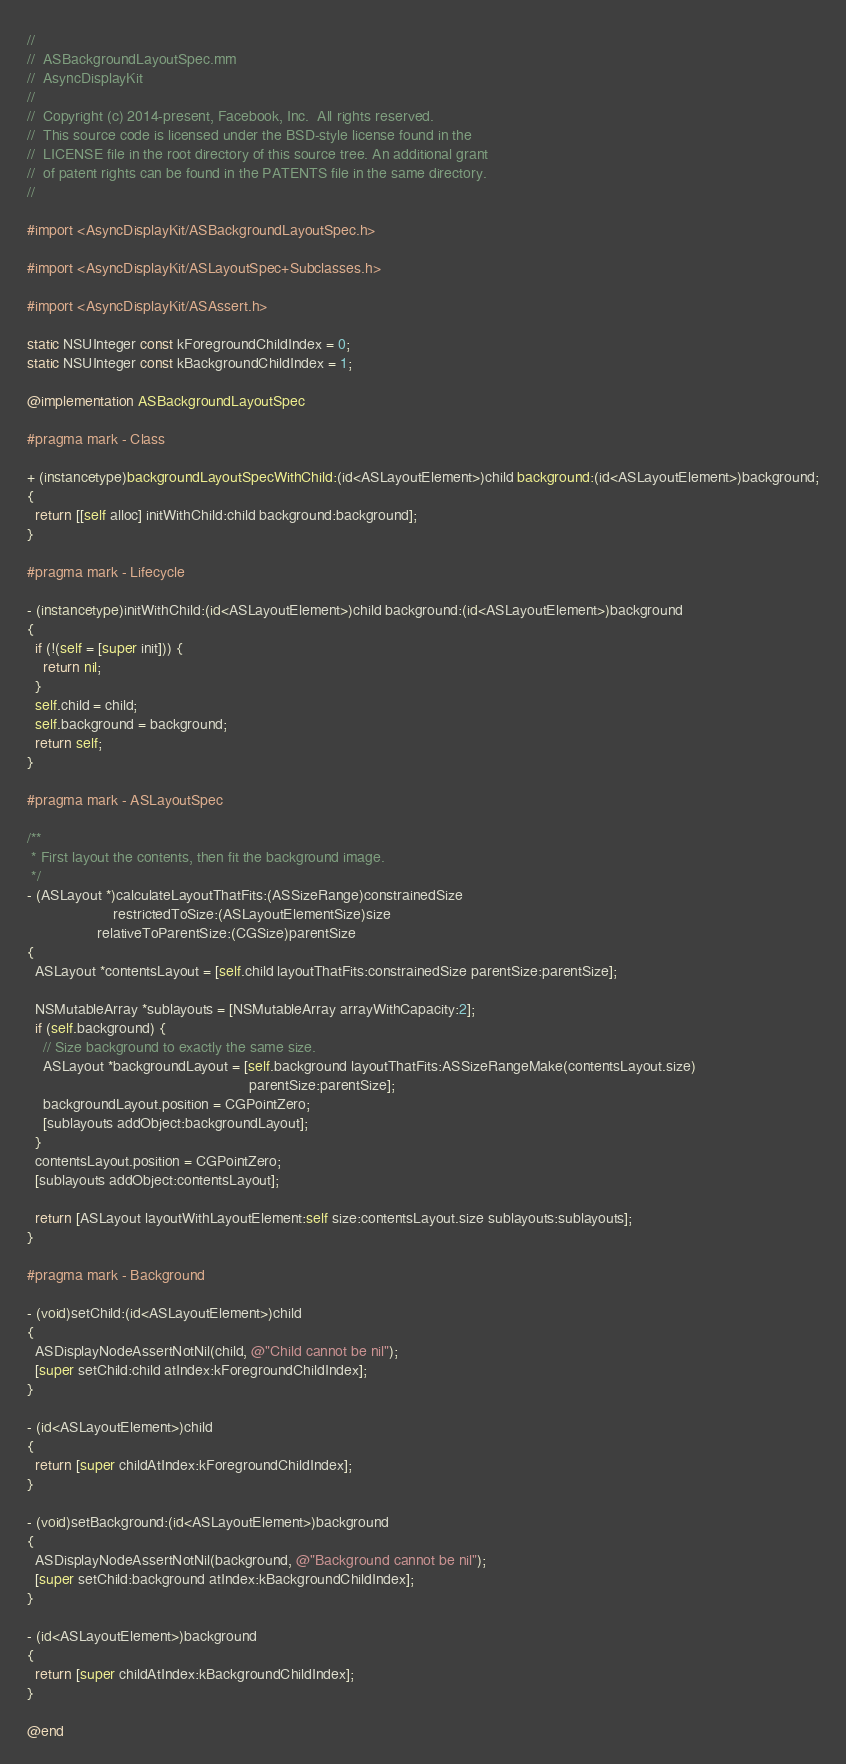Convert code to text. <code><loc_0><loc_0><loc_500><loc_500><_ObjectiveC_>//
//  ASBackgroundLayoutSpec.mm
//  AsyncDisplayKit
//
//  Copyright (c) 2014-present, Facebook, Inc.  All rights reserved.
//  This source code is licensed under the BSD-style license found in the
//  LICENSE file in the root directory of this source tree. An additional grant
//  of patent rights can be found in the PATENTS file in the same directory.
//

#import <AsyncDisplayKit/ASBackgroundLayoutSpec.h>

#import <AsyncDisplayKit/ASLayoutSpec+Subclasses.h>

#import <AsyncDisplayKit/ASAssert.h>

static NSUInteger const kForegroundChildIndex = 0;
static NSUInteger const kBackgroundChildIndex = 1;

@implementation ASBackgroundLayoutSpec

#pragma mark - Class

+ (instancetype)backgroundLayoutSpecWithChild:(id<ASLayoutElement>)child background:(id<ASLayoutElement>)background;
{
  return [[self alloc] initWithChild:child background:background];
}

#pragma mark - Lifecycle

- (instancetype)initWithChild:(id<ASLayoutElement>)child background:(id<ASLayoutElement>)background
{
  if (!(self = [super init])) {
    return nil;
  }
  self.child = child;
  self.background = background;
  return self;
}

#pragma mark - ASLayoutSpec

/**
 * First layout the contents, then fit the background image.
 */
- (ASLayout *)calculateLayoutThatFits:(ASSizeRange)constrainedSize
                     restrictedToSize:(ASLayoutElementSize)size
                 relativeToParentSize:(CGSize)parentSize
{
  ASLayout *contentsLayout = [self.child layoutThatFits:constrainedSize parentSize:parentSize];

  NSMutableArray *sublayouts = [NSMutableArray arrayWithCapacity:2];
  if (self.background) {
    // Size background to exactly the same size.
    ASLayout *backgroundLayout = [self.background layoutThatFits:ASSizeRangeMake(contentsLayout.size)
                                                      parentSize:parentSize];
    backgroundLayout.position = CGPointZero;
    [sublayouts addObject:backgroundLayout];
  }
  contentsLayout.position = CGPointZero;
  [sublayouts addObject:contentsLayout];

  return [ASLayout layoutWithLayoutElement:self size:contentsLayout.size sublayouts:sublayouts];
}

#pragma mark - Background

- (void)setChild:(id<ASLayoutElement>)child
{
  ASDisplayNodeAssertNotNil(child, @"Child cannot be nil");
  [super setChild:child atIndex:kForegroundChildIndex];
}

- (id<ASLayoutElement>)child
{
  return [super childAtIndex:kForegroundChildIndex];
}

- (void)setBackground:(id<ASLayoutElement>)background
{
  ASDisplayNodeAssertNotNil(background, @"Background cannot be nil");
  [super setChild:background atIndex:kBackgroundChildIndex];
}

- (id<ASLayoutElement>)background
{
  return [super childAtIndex:kBackgroundChildIndex];
}

@end
</code> 